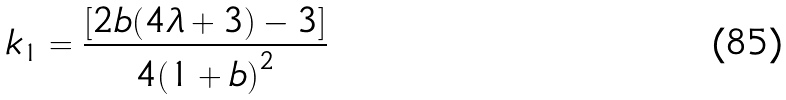Convert formula to latex. <formula><loc_0><loc_0><loc_500><loc_500>k _ { 1 } = \frac { [ 2 b ( 4 \lambda + 3 ) - 3 ] } { 4 { ( 1 + b ) } ^ { 2 } }</formula> 